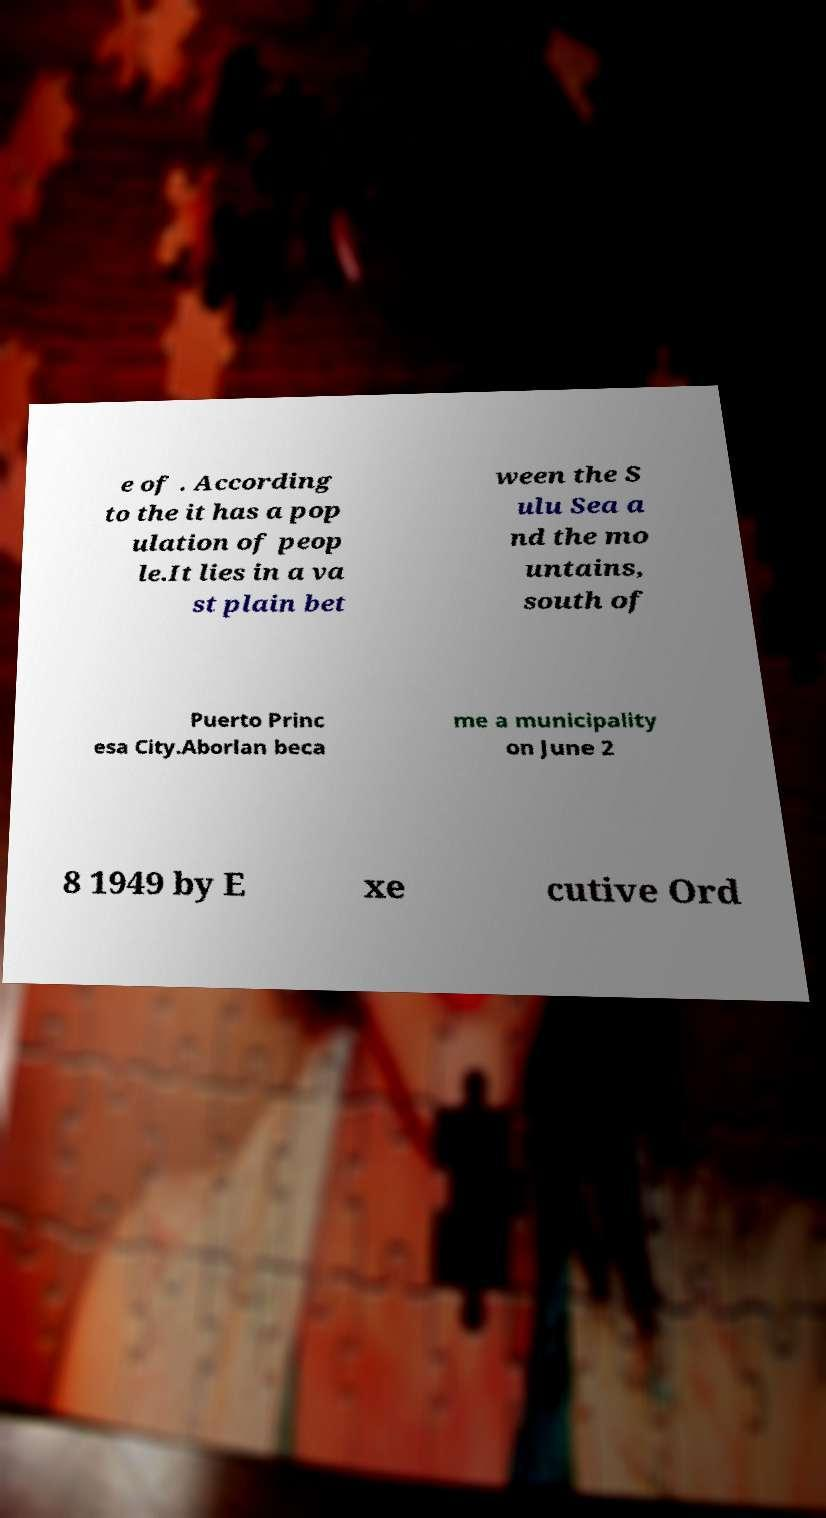Please read and relay the text visible in this image. What does it say? e of . According to the it has a pop ulation of peop le.It lies in a va st plain bet ween the S ulu Sea a nd the mo untains, south of Puerto Princ esa City.Aborlan beca me a municipality on June 2 8 1949 by E xe cutive Ord 